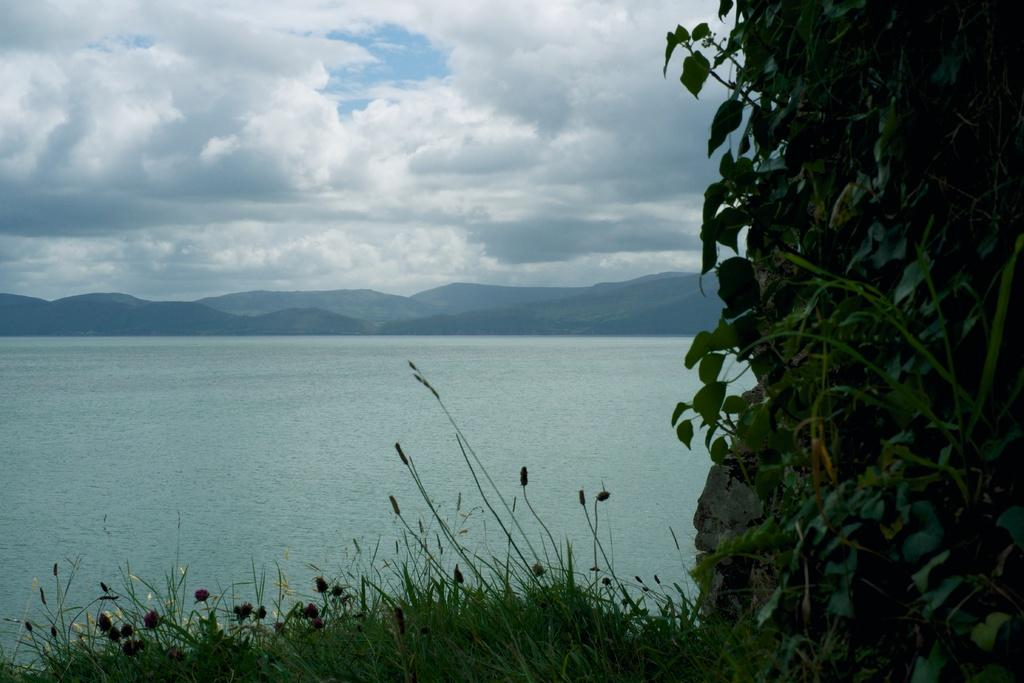What type of natural elements can be seen in the image? There are plants, grass, and water visible in the image. Where are the plants and grass located in the image? The plants and grass are in the front of the image. What is the location of the water in the image? The water is in the middle of the image. What can be seen in the background of the image? There are mountains and a cloudy sky visible in the background of the image. What book is the goat reading in the image? There is no goat or book present in the image. 